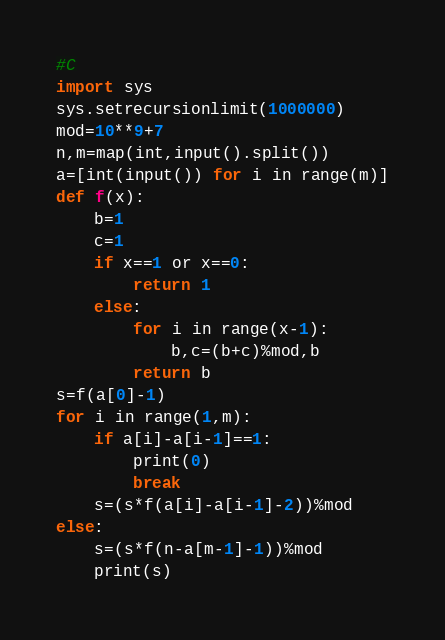<code> <loc_0><loc_0><loc_500><loc_500><_Python_>#C
import sys
sys.setrecursionlimit(1000000)
mod=10**9+7
n,m=map(int,input().split())
a=[int(input()) for i in range(m)]
def f(x):
    b=1
    c=1
    if x==1 or x==0:
        return 1
    else:
        for i in range(x-1):
            b,c=(b+c)%mod,b
        return b
s=f(a[0]-1)
for i in range(1,m):
    if a[i]-a[i-1]==1:
        print(0)
        break
    s=(s*f(a[i]-a[i-1]-2))%mod
else:
    s=(s*f(n-a[m-1]-1))%mod
    print(s)</code> 